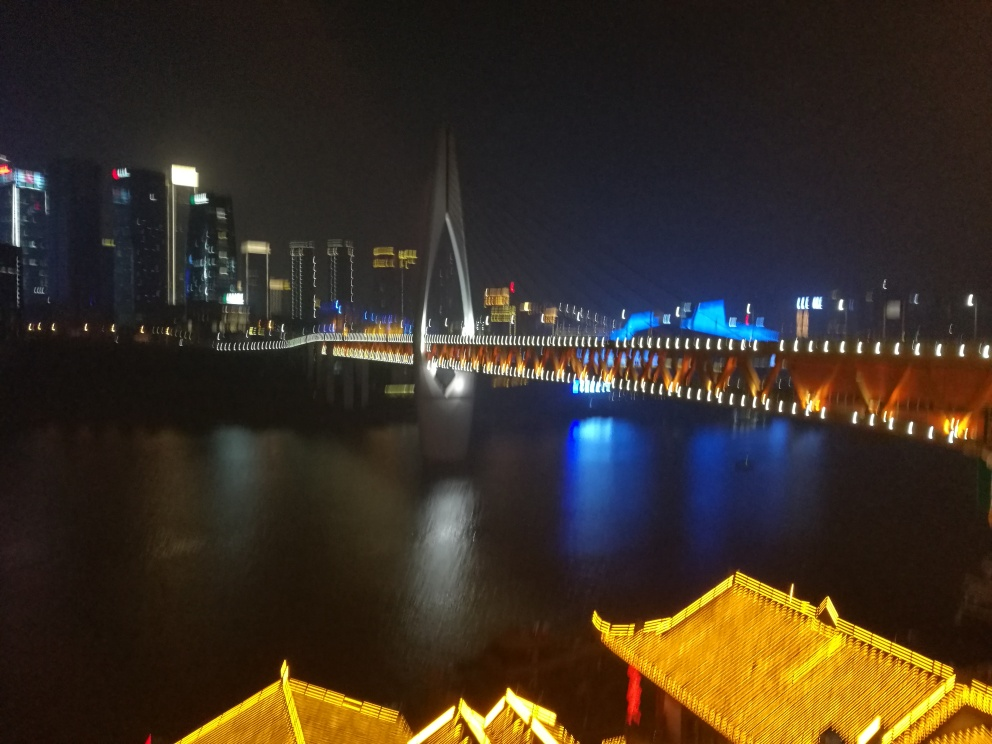Are there any quality issues with this image? Yes, the image appears to be slightly blurred, which suggests there may have been motion or a lack of focus during the capture process. Additionally, there seems to be a high level of noise or graininess, possibly due to the low light conditions or a high ISO setting used in the camera. 